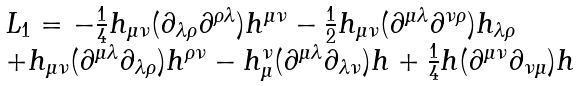<formula> <loc_0><loc_0><loc_500><loc_500>\begin{array} { l } L _ { 1 } = - \frac { 1 } { 4 } h _ { \mu \nu } ( \partial _ { \lambda \rho } \partial ^ { \rho \lambda } ) h ^ { \mu \nu } - \frac { 1 } { 2 } h _ { \mu \nu } ( \partial ^ { \mu \lambda } \partial ^ { \nu \rho } ) h _ { \lambda \rho } \\ + h _ { \mu \nu } ( \partial ^ { \mu \lambda } \partial _ { \lambda \rho } ) h ^ { \rho \nu } - h _ { \mu } ^ { \nu } ( \partial ^ { \mu \lambda } \partial _ { \lambda \nu } ) h + \frac { 1 } { 4 } h ( \partial ^ { \mu \nu } \partial _ { \nu \mu } ) h \end{array}</formula> 